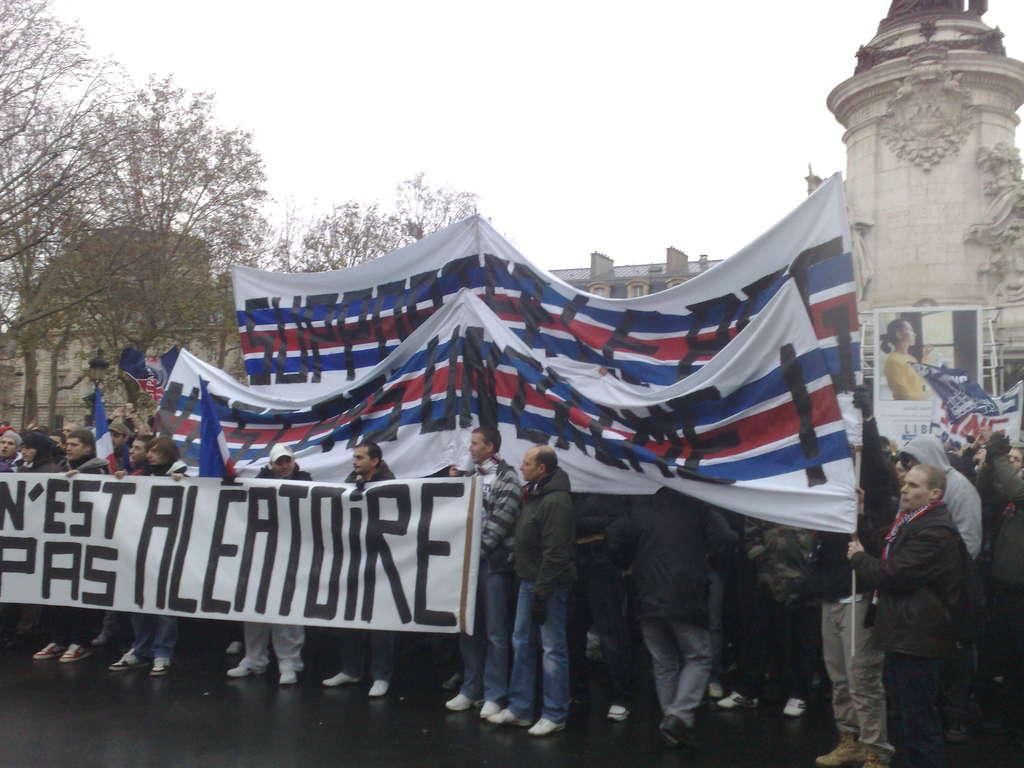What is happening in the image involving the group of people? The people in the image are standing and holding banners. What can be seen in the background of the image? There are trees, a building, and the sky visible in the background of the image. What design is featured on the trees in the image? There are no designs on the trees in the image; they are natural trees. 